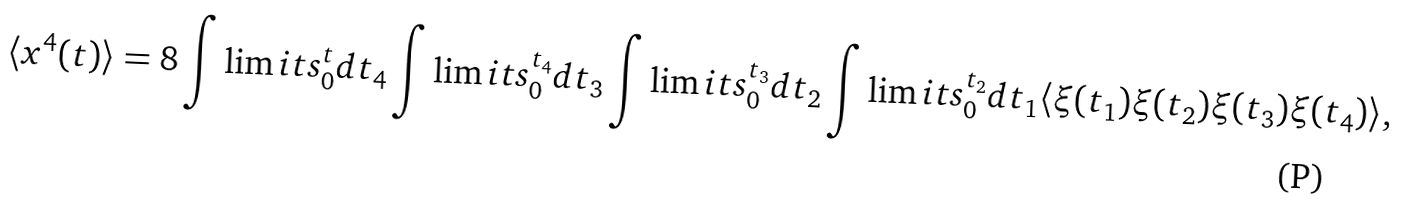<formula> <loc_0><loc_0><loc_500><loc_500>\langle x ^ { 4 } ( t ) \rangle = 8 \int \lim i t s _ { 0 } ^ { t } d t _ { 4 } \int \lim i t s _ { 0 } ^ { t _ { 4 } } d t _ { 3 } \int \lim i t s _ { 0 } ^ { t _ { 3 } } d t _ { 2 } \int \lim i t s _ { 0 } ^ { t _ { 2 } } d t _ { 1 } \langle \xi ( t _ { 1 } ) \xi ( t _ { 2 } ) \xi ( t _ { 3 } ) \xi ( t _ { 4 } ) \rangle ,</formula> 